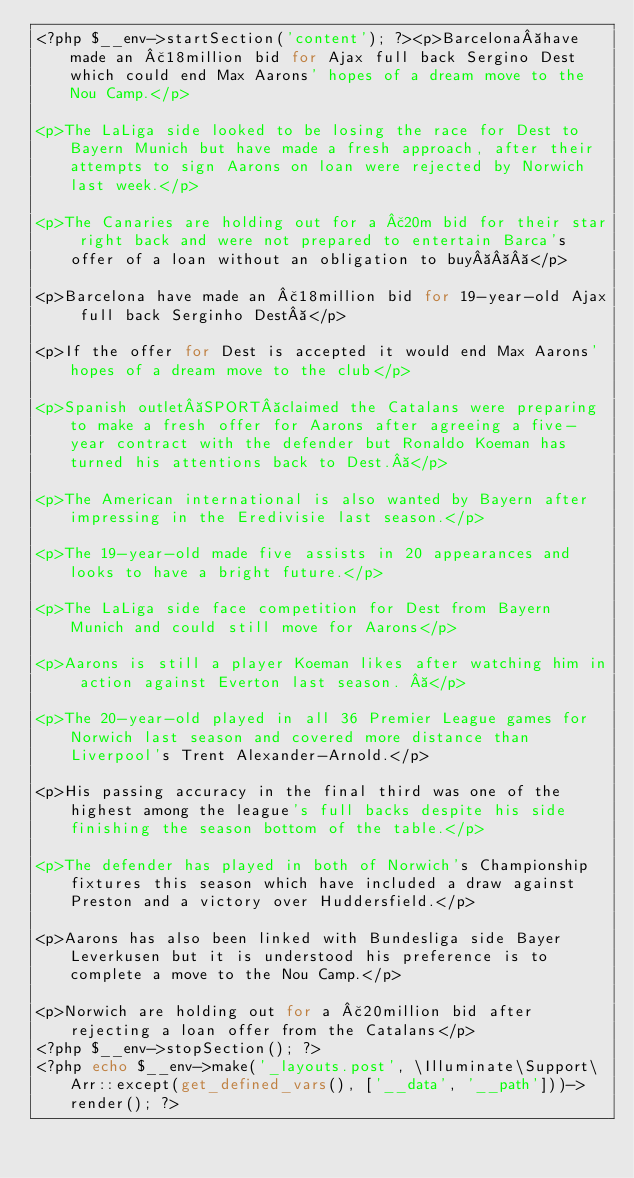Convert code to text. <code><loc_0><loc_0><loc_500><loc_500><_PHP_><?php $__env->startSection('content'); ?><p>Barcelona have made an £18million bid for Ajax full back Sergino Dest which could end Max Aarons' hopes of a dream move to the Nou Camp.</p>

<p>The LaLiga side looked to be losing the race for Dest to Bayern Munich but have made a fresh approach, after their attempts to sign Aarons on loan were rejected by Norwich last week.</p>

<p>The Canaries are holding out for a £20m bid for their star right back and were not prepared to entertain Barca's offer of a loan without an obligation to buy   </p>

<p>Barcelona have made an £18million bid for 19-year-old Ajax full back Serginho Dest </p>

<p>If the offer for Dest is accepted it would end Max Aarons' hopes of a dream move to the club</p>

<p>Spanish outlet SPORT claimed the Catalans were preparing to make a fresh offer for Aarons after agreeing a five-year contract with the defender but Ronaldo Koeman has turned his attentions back to Dest. </p>

<p>The American international is also wanted by Bayern after impressing in the Eredivisie last season.</p>

<p>The 19-year-old made five assists in 20 appearances and looks to have a bright future.</p>

<p>The LaLiga side face competition for Dest from Bayern Munich and could still move for Aarons</p>

<p>Aarons is still a player Koeman likes after watching him in action against Everton last season.  </p>

<p>The 20-year-old played in all 36 Premier League games for Norwich last season and covered more distance than Liverpool's Trent Alexander-Arnold.</p>

<p>His passing accuracy in the final third was one of the highest among the league's full backs despite his side finishing the season bottom of the table.</p>

<p>The defender has played in both of Norwich's Championship fixtures this season which have included a draw against Preston and a victory over Huddersfield.</p>

<p>Aarons has also been linked with Bundesliga side Bayer Leverkusen but it is understood his preference is to complete a move to the Nou Camp.</p>

<p>Norwich are holding out for a £20million bid after rejecting a loan offer from the Catalans</p>
<?php $__env->stopSection(); ?>
<?php echo $__env->make('_layouts.post', \Illuminate\Support\Arr::except(get_defined_vars(), ['__data', '__path']))->render(); ?></code> 